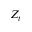Convert formula to latex. <formula><loc_0><loc_0><loc_500><loc_500>Z _ { t }</formula> 